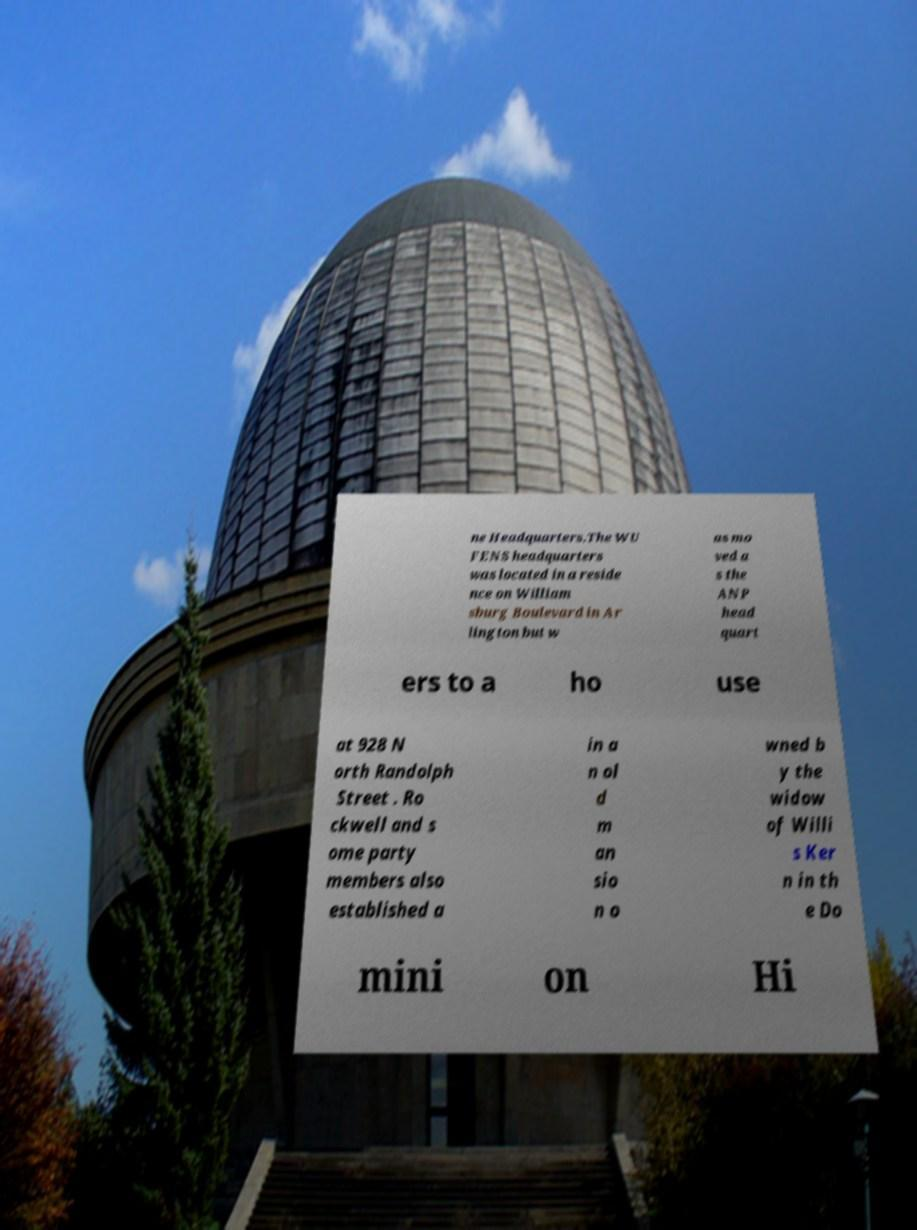Could you assist in decoding the text presented in this image and type it out clearly? ne Headquarters.The WU FENS headquarters was located in a reside nce on William sburg Boulevard in Ar lington but w as mo ved a s the ANP head quart ers to a ho use at 928 N orth Randolph Street . Ro ckwell and s ome party members also established a in a n ol d m an sio n o wned b y the widow of Willi s Ker n in th e Do mini on Hi 